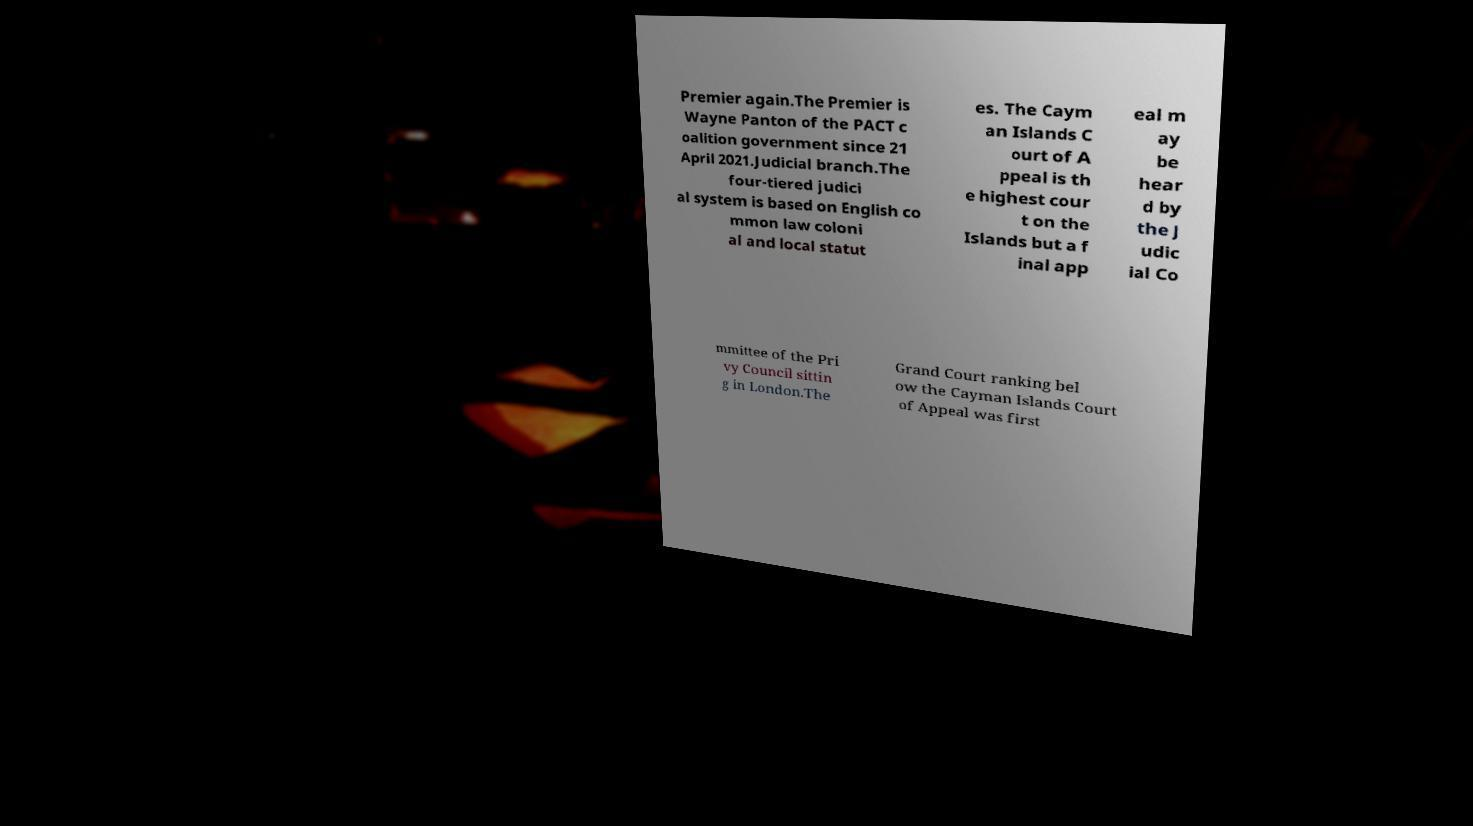What messages or text are displayed in this image? I need them in a readable, typed format. Premier again.The Premier is Wayne Panton of the PACT c oalition government since 21 April 2021.Judicial branch.The four-tiered judici al system is based on English co mmon law coloni al and local statut es. The Caym an Islands C ourt of A ppeal is th e highest cour t on the Islands but a f inal app eal m ay be hear d by the J udic ial Co mmittee of the Pri vy Council sittin g in London.The Grand Court ranking bel ow the Cayman Islands Court of Appeal was first 